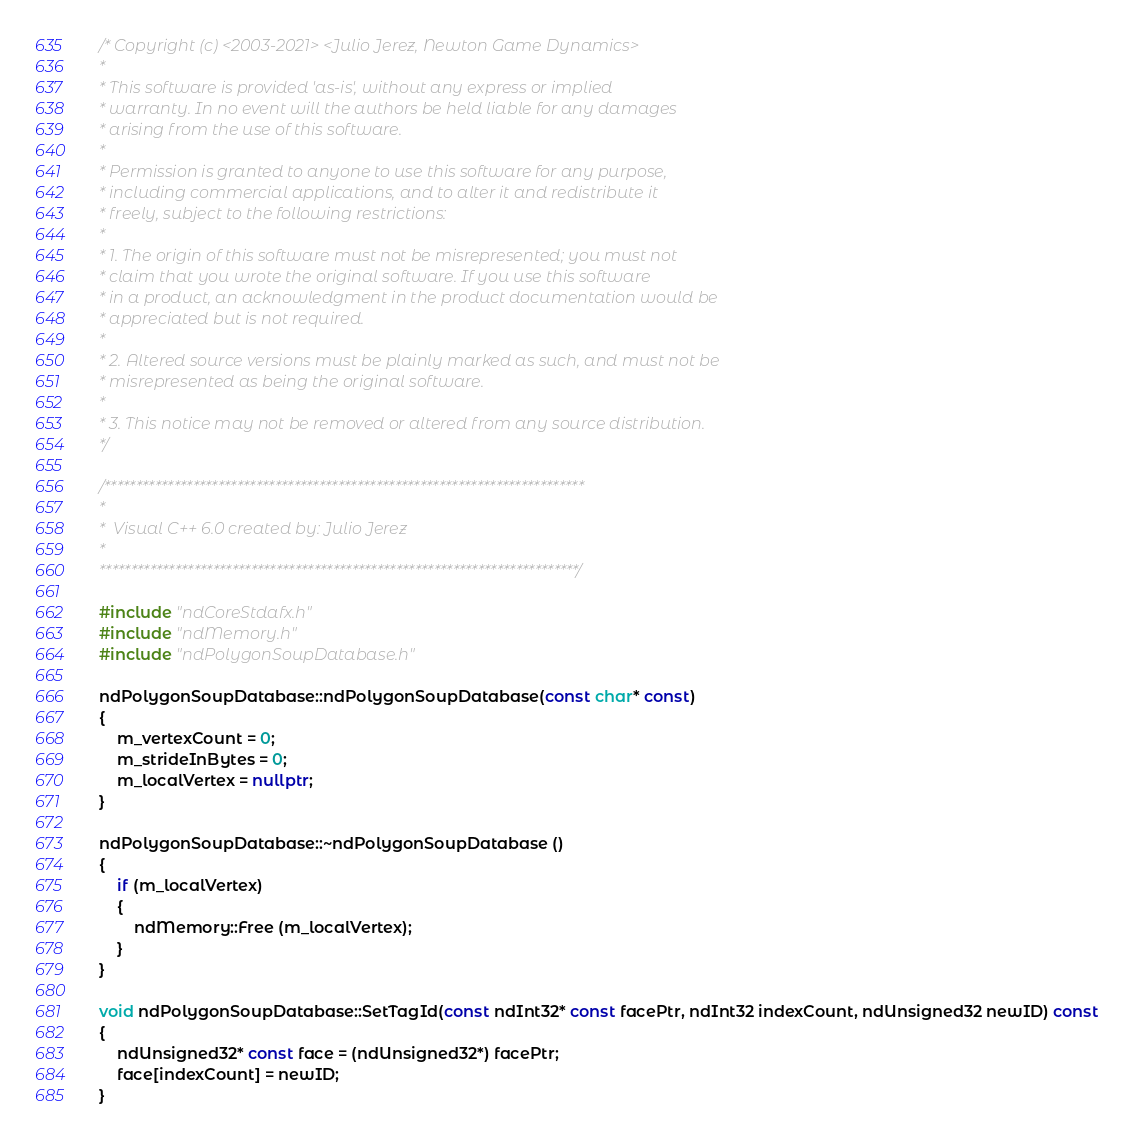<code> <loc_0><loc_0><loc_500><loc_500><_C++_>/* Copyright (c) <2003-2021> <Julio Jerez, Newton Game Dynamics>
* 
* This software is provided 'as-is', without any express or implied
* warranty. In no event will the authors be held liable for any damages
* arising from the use of this software.
* 
* Permission is granted to anyone to use this software for any purpose,
* including commercial applications, and to alter it and redistribute it
* freely, subject to the following restrictions:
* 
* 1. The origin of this software must not be misrepresented; you must not
* claim that you wrote the original software. If you use this software
* in a product, an acknowledgment in the product documentation would be
* appreciated but is not required.
* 
* 2. Altered source versions must be plainly marked as such, and must not be
* misrepresented as being the original software.
* 
* 3. This notice may not be removed or altered from any source distribution.
*/

/****************************************************************************
*
*  Visual C++ 6.0 created by: Julio Jerez
*
****************************************************************************/

#include "ndCoreStdafx.h"
#include "ndMemory.h"
#include "ndPolygonSoupDatabase.h"

ndPolygonSoupDatabase::ndPolygonSoupDatabase(const char* const)
{
	m_vertexCount = 0;
	m_strideInBytes = 0;
	m_localVertex = nullptr;
}

ndPolygonSoupDatabase::~ndPolygonSoupDatabase ()
{
	if (m_localVertex) 
	{
		ndMemory::Free (m_localVertex);
	}
}

void ndPolygonSoupDatabase::SetTagId(const ndInt32* const facePtr, ndInt32 indexCount, ndUnsigned32 newID) const
{
	ndUnsigned32* const face = (ndUnsigned32*) facePtr;
	face[indexCount] = newID;
}


</code> 